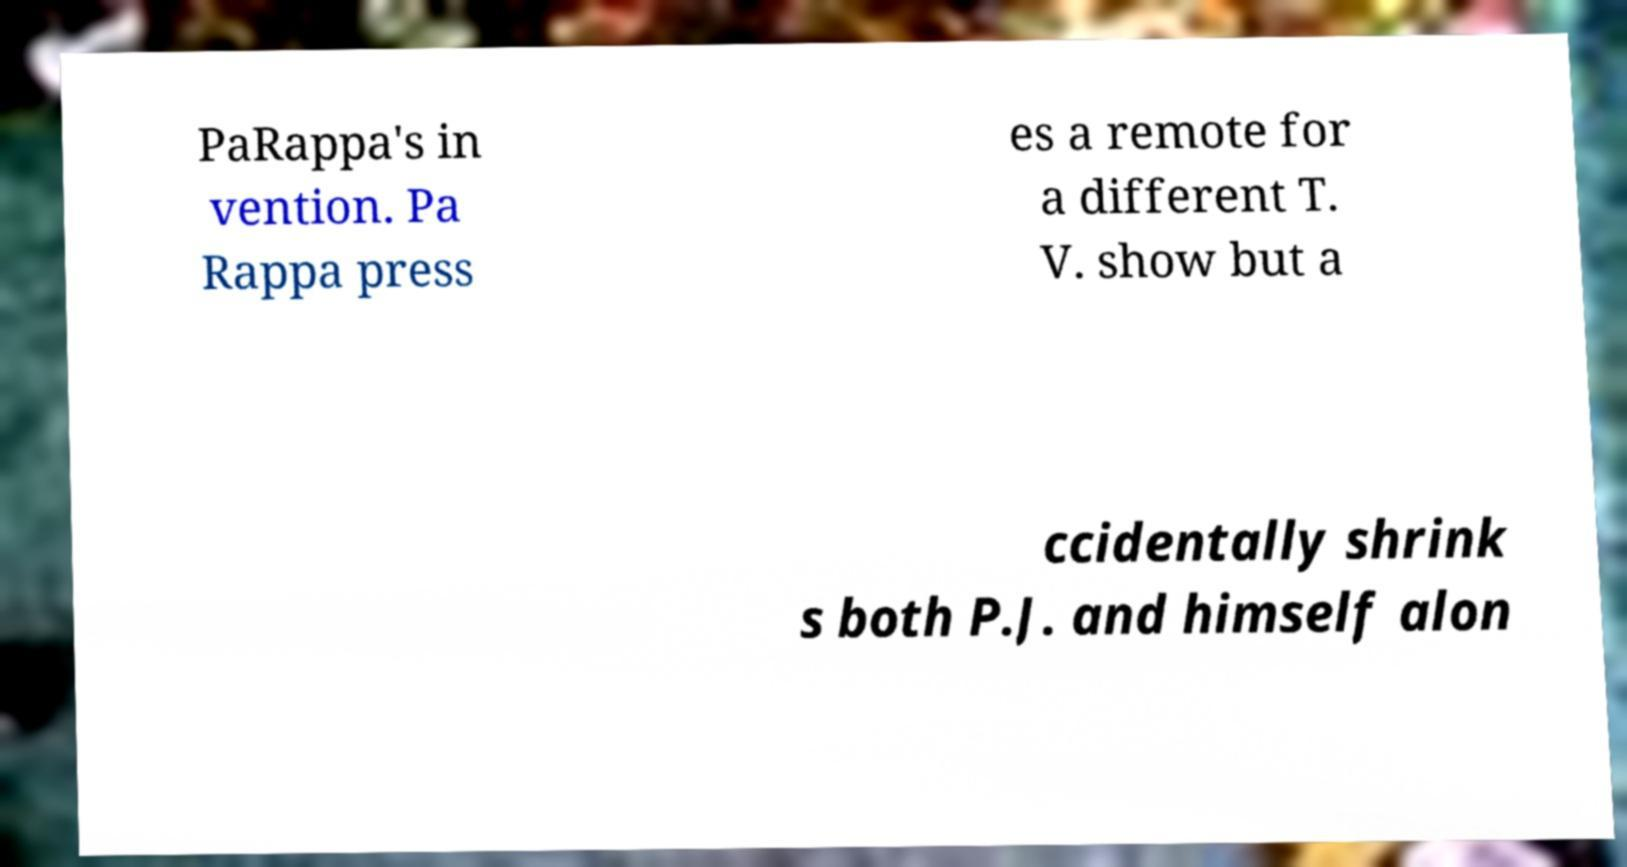Please read and relay the text visible in this image. What does it say? PaRappa's in vention. Pa Rappa press es a remote for a different T. V. show but a ccidentally shrink s both P.J. and himself alon 